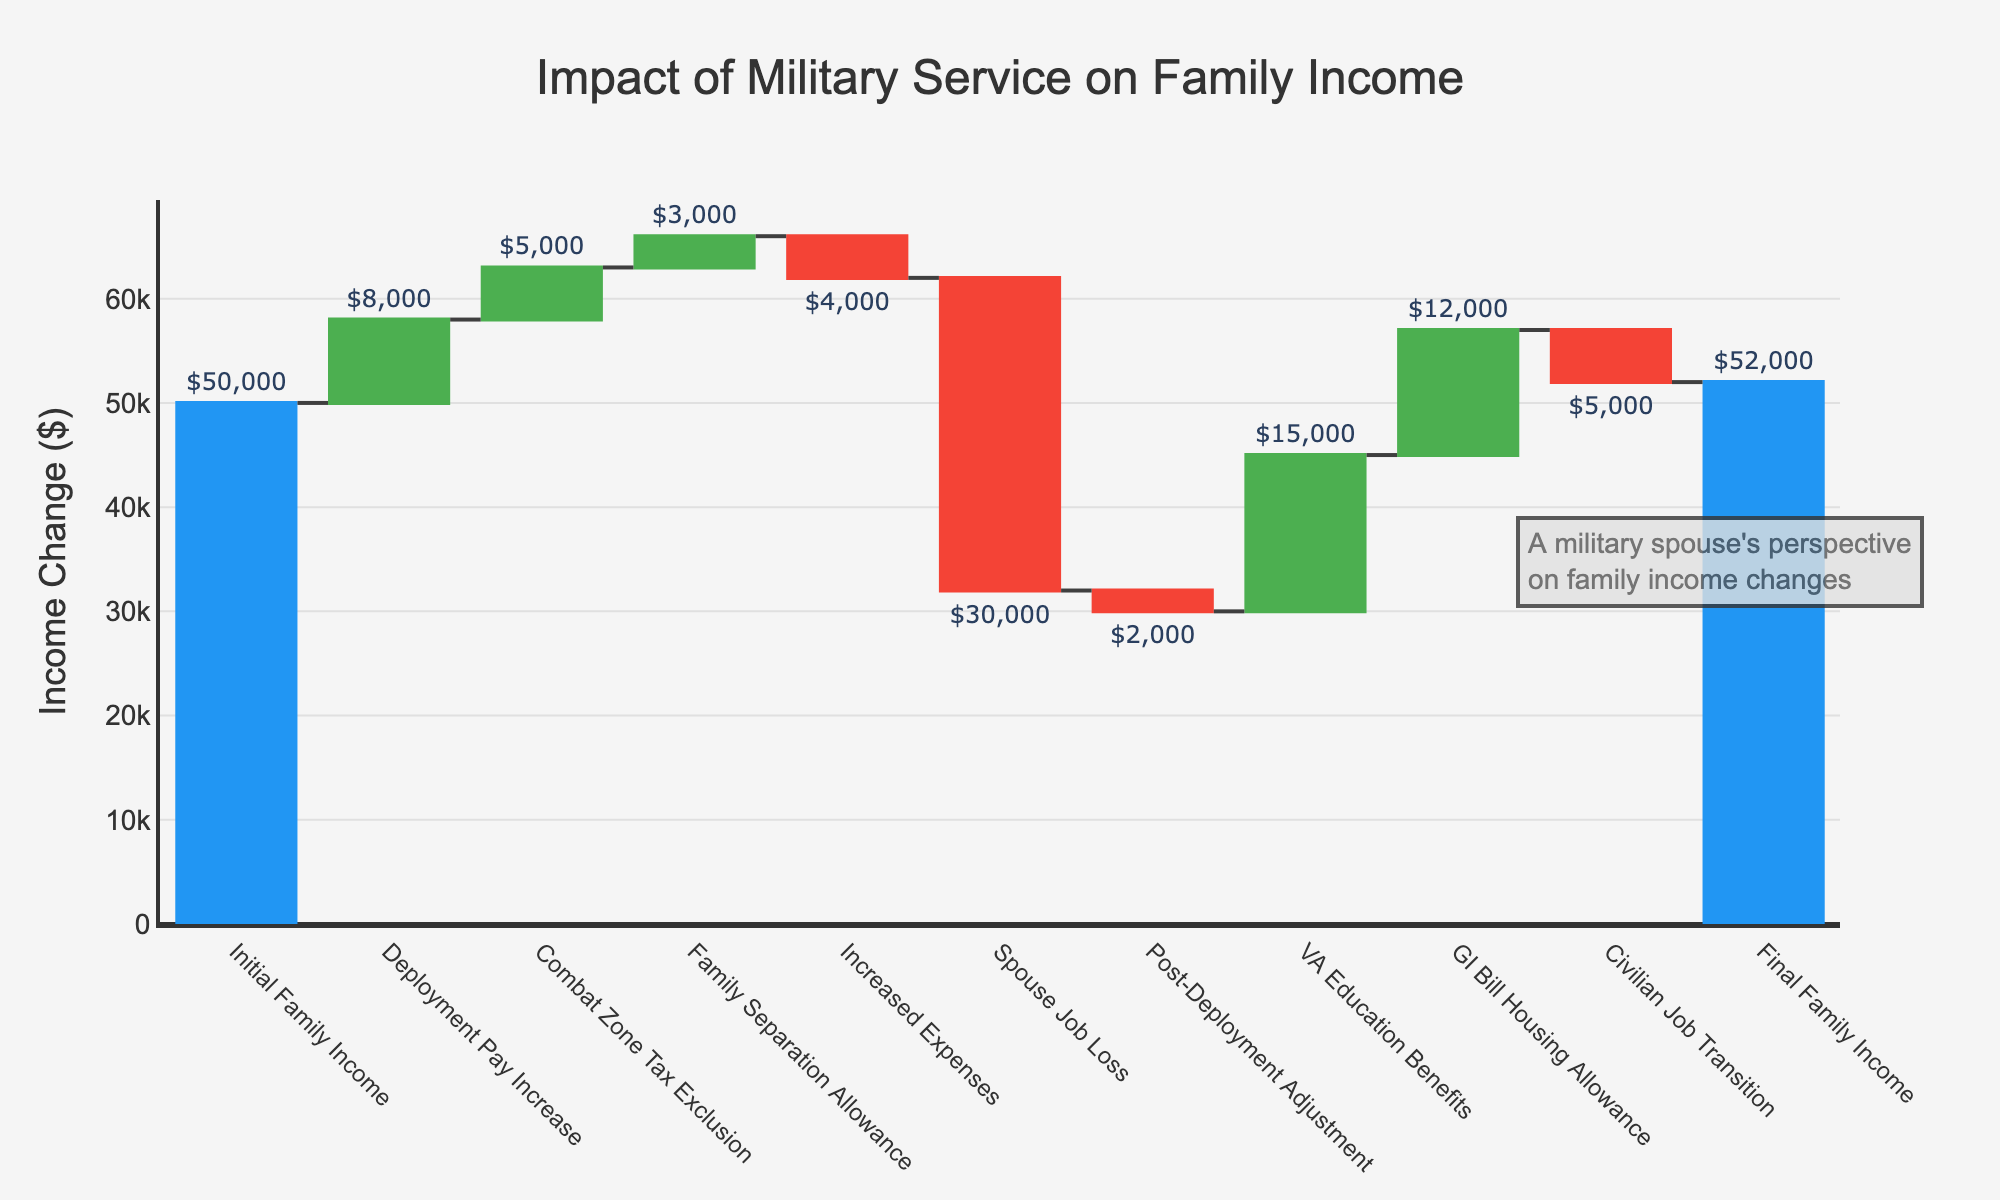What is the title of the chart? The title of the chart is displayed at the top, and it reads "Impact of Military Service on Family Income".
Answer: Impact of Military Service on Family Income How much did the Initial Family Income change due to Deployment Pay Increase? We look at the data category labeled "Deployment Pay Increase", which shows a change of $8,000 in family income due to deployment.
Answer: $8,000 What is the Final Family Income? The final bar represents the "Final Family Income" and is labeled as $52,000.
Answer: $52,000 What is the net change in family income from Spouse Job Loss and Post-Deployment Adjustment? The change from Spouse Job Loss is -$30,000 and from Post-Deployment Adjustment is -$2,000. Summing these, the net change is -$30,000 + -$2,000 = -$32,000.
Answer: -$32,000 Which income change category had the highest positive impact? By observing the height of the bars colored to indicate positive changes, the "GI Bill Housing Allowance" had the highest positive impact at $12,000.
Answer: GI Bill Housing Allowance How do Increased Expenses compare to Combat Zone Tax Exclusion in terms of magnitude of impact? The "Increased Expenses" bar shows a change of -$4,000 while the "Combat Zone Tax Exclusion" bar shows a change of $5,000. The Combat Zone Tax Exclusion had a slightly stronger impact in magnitude compared to Increased Expenses.
Answer: Combat Zone Tax Exclusion > Increased Expenses Excluding initial and final incomes, which category had the highest negative impact on family income? Excluding Initial and Final Family Income, the bar showing the largest decrease (colored red) is "Spouse Job Loss" with a value of -$30,000.
Answer: Spouse Job Loss What is the sum of all positive impacts on family income? Sum of the positive values: Deployment Pay Increase ($8,000) + Combat Zone Tax Exclusion ($5,000) + Family Separation Allowance ($3,000) + VA Education Benefits ($15,000) + GI Bill Housing Allowance ($12,000). The total is $8,000 + $5,000 + $3,000 + $15,000 + $12,000 = $43,000.
Answer: $43,000 How does the final income compare to the initial income after considering all adjustments? The Initial Family Income is $50,000, and the Final Family Income is $52,000. This means the family income increased by $52,000 - $50,000 = $2,000.
Answer: Increased by $2,000 